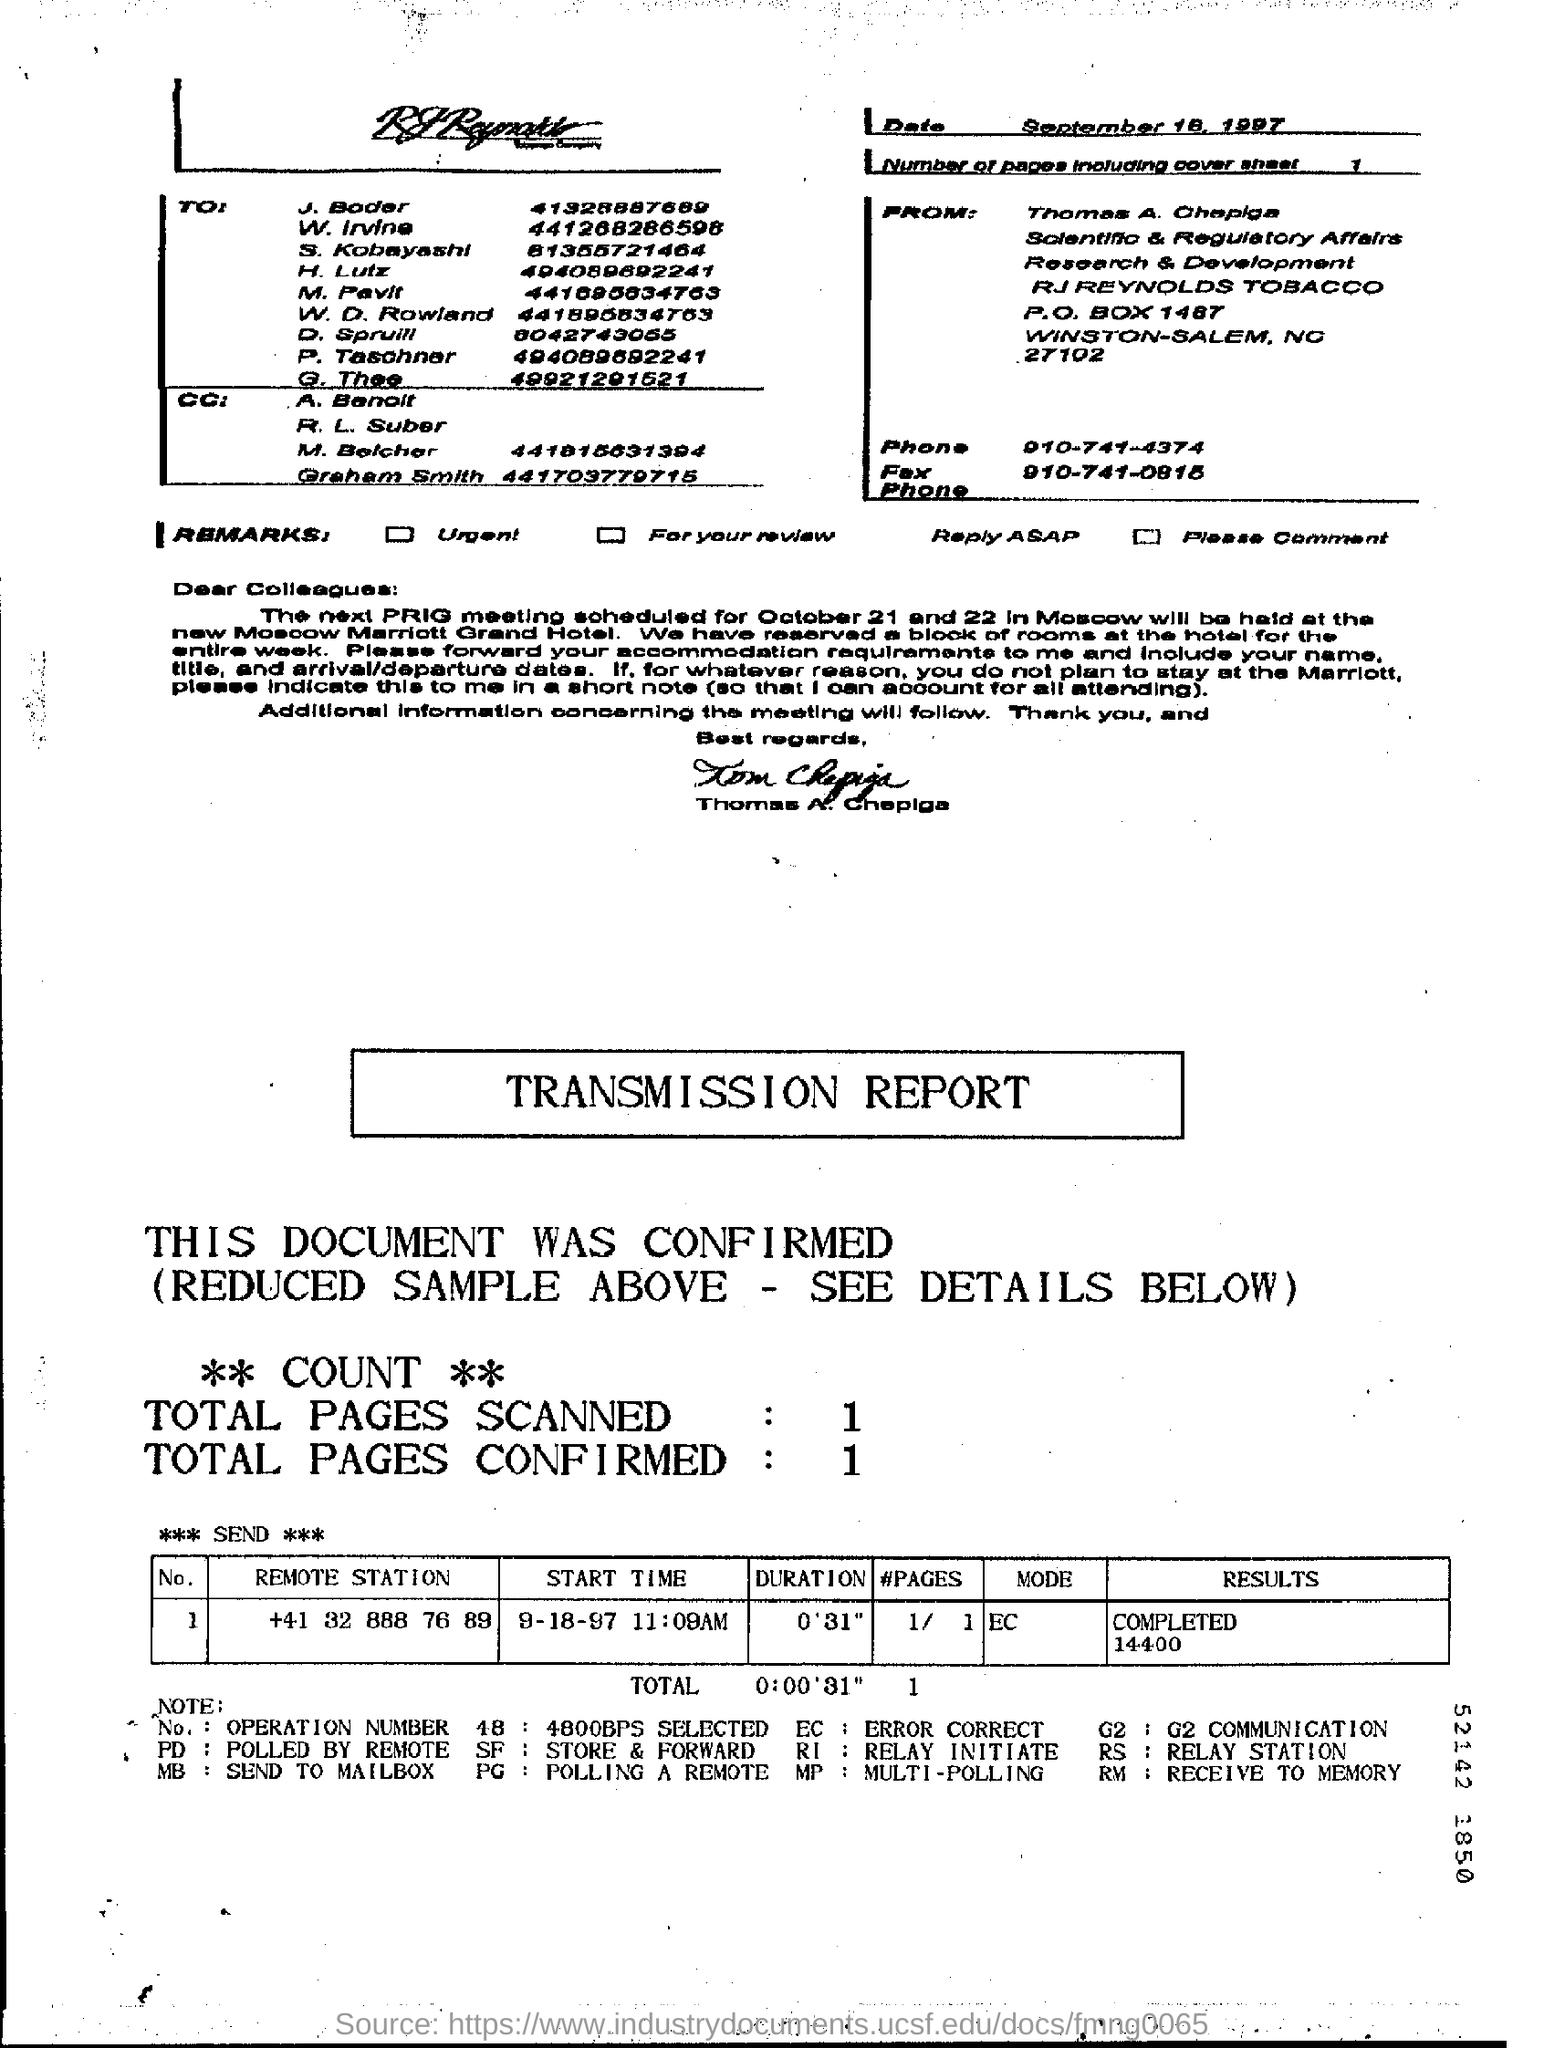Mention a couple of crucial points in this snapshot. On September 18, 1997, the date was mentioned at the top right corner of the page. The total number of pages scanned ranges from 1 to...". There are one page (including the cover sheet) in total. 